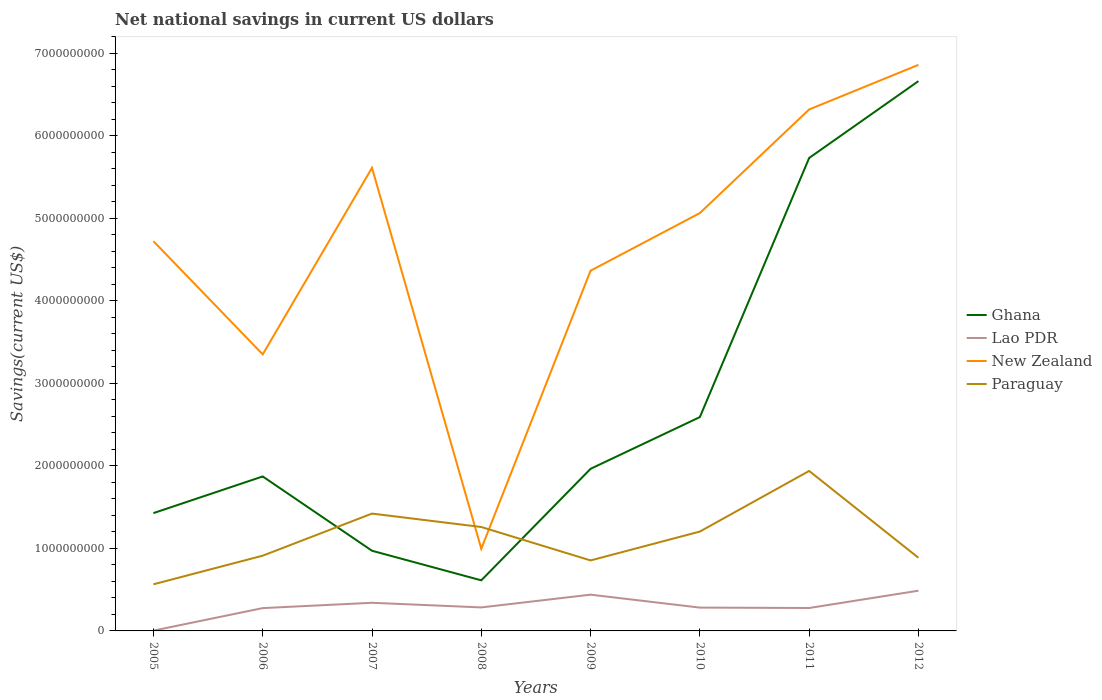How many different coloured lines are there?
Give a very brief answer. 4. Is the number of lines equal to the number of legend labels?
Your answer should be very brief. Yes. Across all years, what is the maximum net national savings in New Zealand?
Keep it short and to the point. 9.96e+08. In which year was the net national savings in New Zealand maximum?
Ensure brevity in your answer.  2008. What is the total net national savings in Lao PDR in the graph?
Ensure brevity in your answer.  -2.10e+08. What is the difference between the highest and the second highest net national savings in New Zealand?
Provide a short and direct response. 5.86e+09. How many lines are there?
Make the answer very short. 4. Are the values on the major ticks of Y-axis written in scientific E-notation?
Make the answer very short. No. Where does the legend appear in the graph?
Offer a very short reply. Center right. How many legend labels are there?
Offer a very short reply. 4. How are the legend labels stacked?
Your response must be concise. Vertical. What is the title of the graph?
Make the answer very short. Net national savings in current US dollars. What is the label or title of the Y-axis?
Provide a succinct answer. Savings(current US$). What is the Savings(current US$) of Ghana in 2005?
Give a very brief answer. 1.43e+09. What is the Savings(current US$) of Lao PDR in 2005?
Offer a very short reply. 3.68e+06. What is the Savings(current US$) in New Zealand in 2005?
Your answer should be compact. 4.72e+09. What is the Savings(current US$) of Paraguay in 2005?
Keep it short and to the point. 5.65e+08. What is the Savings(current US$) in Ghana in 2006?
Your response must be concise. 1.87e+09. What is the Savings(current US$) in Lao PDR in 2006?
Offer a very short reply. 2.77e+08. What is the Savings(current US$) in New Zealand in 2006?
Make the answer very short. 3.35e+09. What is the Savings(current US$) of Paraguay in 2006?
Provide a short and direct response. 9.12e+08. What is the Savings(current US$) of Ghana in 2007?
Your answer should be very brief. 9.72e+08. What is the Savings(current US$) of Lao PDR in 2007?
Your answer should be compact. 3.41e+08. What is the Savings(current US$) in New Zealand in 2007?
Give a very brief answer. 5.61e+09. What is the Savings(current US$) of Paraguay in 2007?
Ensure brevity in your answer.  1.42e+09. What is the Savings(current US$) in Ghana in 2008?
Ensure brevity in your answer.  6.13e+08. What is the Savings(current US$) in Lao PDR in 2008?
Your answer should be very brief. 2.85e+08. What is the Savings(current US$) in New Zealand in 2008?
Offer a very short reply. 9.96e+08. What is the Savings(current US$) in Paraguay in 2008?
Keep it short and to the point. 1.26e+09. What is the Savings(current US$) in Ghana in 2009?
Offer a very short reply. 1.96e+09. What is the Savings(current US$) of Lao PDR in 2009?
Your answer should be very brief. 4.39e+08. What is the Savings(current US$) in New Zealand in 2009?
Keep it short and to the point. 4.37e+09. What is the Savings(current US$) in Paraguay in 2009?
Offer a terse response. 8.54e+08. What is the Savings(current US$) of Ghana in 2010?
Keep it short and to the point. 2.59e+09. What is the Savings(current US$) in Lao PDR in 2010?
Your answer should be very brief. 2.83e+08. What is the Savings(current US$) of New Zealand in 2010?
Provide a succinct answer. 5.06e+09. What is the Savings(current US$) of Paraguay in 2010?
Ensure brevity in your answer.  1.20e+09. What is the Savings(current US$) in Ghana in 2011?
Offer a terse response. 5.73e+09. What is the Savings(current US$) in Lao PDR in 2011?
Your answer should be compact. 2.78e+08. What is the Savings(current US$) of New Zealand in 2011?
Make the answer very short. 6.32e+09. What is the Savings(current US$) in Paraguay in 2011?
Offer a very short reply. 1.94e+09. What is the Savings(current US$) of Ghana in 2012?
Make the answer very short. 6.66e+09. What is the Savings(current US$) in Lao PDR in 2012?
Make the answer very short. 4.88e+08. What is the Savings(current US$) of New Zealand in 2012?
Provide a short and direct response. 6.86e+09. What is the Savings(current US$) of Paraguay in 2012?
Your answer should be compact. 8.86e+08. Across all years, what is the maximum Savings(current US$) of Ghana?
Make the answer very short. 6.66e+09. Across all years, what is the maximum Savings(current US$) in Lao PDR?
Your answer should be very brief. 4.88e+08. Across all years, what is the maximum Savings(current US$) of New Zealand?
Keep it short and to the point. 6.86e+09. Across all years, what is the maximum Savings(current US$) of Paraguay?
Ensure brevity in your answer.  1.94e+09. Across all years, what is the minimum Savings(current US$) of Ghana?
Offer a very short reply. 6.13e+08. Across all years, what is the minimum Savings(current US$) in Lao PDR?
Give a very brief answer. 3.68e+06. Across all years, what is the minimum Savings(current US$) of New Zealand?
Your answer should be very brief. 9.96e+08. Across all years, what is the minimum Savings(current US$) in Paraguay?
Give a very brief answer. 5.65e+08. What is the total Savings(current US$) in Ghana in the graph?
Provide a succinct answer. 2.18e+1. What is the total Savings(current US$) in Lao PDR in the graph?
Offer a terse response. 2.39e+09. What is the total Savings(current US$) in New Zealand in the graph?
Make the answer very short. 3.73e+1. What is the total Savings(current US$) of Paraguay in the graph?
Provide a succinct answer. 9.04e+09. What is the difference between the Savings(current US$) in Ghana in 2005 and that in 2006?
Your answer should be very brief. -4.44e+08. What is the difference between the Savings(current US$) in Lao PDR in 2005 and that in 2006?
Offer a terse response. -2.73e+08. What is the difference between the Savings(current US$) in New Zealand in 2005 and that in 2006?
Provide a short and direct response. 1.37e+09. What is the difference between the Savings(current US$) in Paraguay in 2005 and that in 2006?
Your answer should be compact. -3.47e+08. What is the difference between the Savings(current US$) in Ghana in 2005 and that in 2007?
Offer a very short reply. 4.56e+08. What is the difference between the Savings(current US$) in Lao PDR in 2005 and that in 2007?
Offer a terse response. -3.37e+08. What is the difference between the Savings(current US$) of New Zealand in 2005 and that in 2007?
Offer a terse response. -8.89e+08. What is the difference between the Savings(current US$) in Paraguay in 2005 and that in 2007?
Provide a short and direct response. -8.57e+08. What is the difference between the Savings(current US$) of Ghana in 2005 and that in 2008?
Offer a very short reply. 8.15e+08. What is the difference between the Savings(current US$) of Lao PDR in 2005 and that in 2008?
Give a very brief answer. -2.81e+08. What is the difference between the Savings(current US$) in New Zealand in 2005 and that in 2008?
Offer a very short reply. 3.73e+09. What is the difference between the Savings(current US$) of Paraguay in 2005 and that in 2008?
Ensure brevity in your answer.  -6.94e+08. What is the difference between the Savings(current US$) of Ghana in 2005 and that in 2009?
Your answer should be very brief. -5.37e+08. What is the difference between the Savings(current US$) in Lao PDR in 2005 and that in 2009?
Give a very brief answer. -4.36e+08. What is the difference between the Savings(current US$) of New Zealand in 2005 and that in 2009?
Provide a short and direct response. 3.58e+08. What is the difference between the Savings(current US$) in Paraguay in 2005 and that in 2009?
Provide a short and direct response. -2.89e+08. What is the difference between the Savings(current US$) in Ghana in 2005 and that in 2010?
Provide a short and direct response. -1.16e+09. What is the difference between the Savings(current US$) of Lao PDR in 2005 and that in 2010?
Ensure brevity in your answer.  -2.79e+08. What is the difference between the Savings(current US$) in New Zealand in 2005 and that in 2010?
Offer a very short reply. -3.41e+08. What is the difference between the Savings(current US$) in Paraguay in 2005 and that in 2010?
Provide a succinct answer. -6.39e+08. What is the difference between the Savings(current US$) in Ghana in 2005 and that in 2011?
Make the answer very short. -4.30e+09. What is the difference between the Savings(current US$) in Lao PDR in 2005 and that in 2011?
Offer a terse response. -2.74e+08. What is the difference between the Savings(current US$) of New Zealand in 2005 and that in 2011?
Your response must be concise. -1.60e+09. What is the difference between the Savings(current US$) of Paraguay in 2005 and that in 2011?
Your answer should be compact. -1.37e+09. What is the difference between the Savings(current US$) of Ghana in 2005 and that in 2012?
Provide a short and direct response. -5.24e+09. What is the difference between the Savings(current US$) of Lao PDR in 2005 and that in 2012?
Keep it short and to the point. -4.84e+08. What is the difference between the Savings(current US$) in New Zealand in 2005 and that in 2012?
Your answer should be compact. -2.14e+09. What is the difference between the Savings(current US$) of Paraguay in 2005 and that in 2012?
Provide a short and direct response. -3.21e+08. What is the difference between the Savings(current US$) in Ghana in 2006 and that in 2007?
Offer a terse response. 9.01e+08. What is the difference between the Savings(current US$) of Lao PDR in 2006 and that in 2007?
Ensure brevity in your answer.  -6.46e+07. What is the difference between the Savings(current US$) in New Zealand in 2006 and that in 2007?
Your answer should be very brief. -2.26e+09. What is the difference between the Savings(current US$) in Paraguay in 2006 and that in 2007?
Ensure brevity in your answer.  -5.10e+08. What is the difference between the Savings(current US$) in Ghana in 2006 and that in 2008?
Make the answer very short. 1.26e+09. What is the difference between the Savings(current US$) in Lao PDR in 2006 and that in 2008?
Your answer should be very brief. -8.35e+06. What is the difference between the Savings(current US$) of New Zealand in 2006 and that in 2008?
Offer a terse response. 2.36e+09. What is the difference between the Savings(current US$) in Paraguay in 2006 and that in 2008?
Provide a short and direct response. -3.47e+08. What is the difference between the Savings(current US$) in Ghana in 2006 and that in 2009?
Your answer should be very brief. -9.25e+07. What is the difference between the Savings(current US$) of Lao PDR in 2006 and that in 2009?
Provide a short and direct response. -1.63e+08. What is the difference between the Savings(current US$) in New Zealand in 2006 and that in 2009?
Provide a short and direct response. -1.01e+09. What is the difference between the Savings(current US$) in Paraguay in 2006 and that in 2009?
Ensure brevity in your answer.  5.76e+07. What is the difference between the Savings(current US$) of Ghana in 2006 and that in 2010?
Ensure brevity in your answer.  -7.19e+08. What is the difference between the Savings(current US$) of Lao PDR in 2006 and that in 2010?
Give a very brief answer. -6.13e+06. What is the difference between the Savings(current US$) of New Zealand in 2006 and that in 2010?
Provide a short and direct response. -1.71e+09. What is the difference between the Savings(current US$) in Paraguay in 2006 and that in 2010?
Make the answer very short. -2.92e+08. What is the difference between the Savings(current US$) of Ghana in 2006 and that in 2011?
Offer a terse response. -3.86e+09. What is the difference between the Savings(current US$) of Lao PDR in 2006 and that in 2011?
Give a very brief answer. -1.20e+06. What is the difference between the Savings(current US$) of New Zealand in 2006 and that in 2011?
Your response must be concise. -2.97e+09. What is the difference between the Savings(current US$) in Paraguay in 2006 and that in 2011?
Give a very brief answer. -1.03e+09. What is the difference between the Savings(current US$) of Ghana in 2006 and that in 2012?
Give a very brief answer. -4.79e+09. What is the difference between the Savings(current US$) of Lao PDR in 2006 and that in 2012?
Offer a very short reply. -2.11e+08. What is the difference between the Savings(current US$) of New Zealand in 2006 and that in 2012?
Provide a short and direct response. -3.51e+09. What is the difference between the Savings(current US$) of Paraguay in 2006 and that in 2012?
Provide a succinct answer. 2.55e+07. What is the difference between the Savings(current US$) in Ghana in 2007 and that in 2008?
Provide a succinct answer. 3.59e+08. What is the difference between the Savings(current US$) of Lao PDR in 2007 and that in 2008?
Ensure brevity in your answer.  5.62e+07. What is the difference between the Savings(current US$) of New Zealand in 2007 and that in 2008?
Offer a terse response. 4.62e+09. What is the difference between the Savings(current US$) in Paraguay in 2007 and that in 2008?
Offer a terse response. 1.63e+08. What is the difference between the Savings(current US$) of Ghana in 2007 and that in 2009?
Keep it short and to the point. -9.93e+08. What is the difference between the Savings(current US$) of Lao PDR in 2007 and that in 2009?
Provide a short and direct response. -9.83e+07. What is the difference between the Savings(current US$) of New Zealand in 2007 and that in 2009?
Give a very brief answer. 1.25e+09. What is the difference between the Savings(current US$) of Paraguay in 2007 and that in 2009?
Offer a very short reply. 5.68e+08. What is the difference between the Savings(current US$) in Ghana in 2007 and that in 2010?
Keep it short and to the point. -1.62e+09. What is the difference between the Savings(current US$) in Lao PDR in 2007 and that in 2010?
Your answer should be compact. 5.84e+07. What is the difference between the Savings(current US$) in New Zealand in 2007 and that in 2010?
Give a very brief answer. 5.48e+08. What is the difference between the Savings(current US$) in Paraguay in 2007 and that in 2010?
Provide a short and direct response. 2.18e+08. What is the difference between the Savings(current US$) of Ghana in 2007 and that in 2011?
Give a very brief answer. -4.76e+09. What is the difference between the Savings(current US$) of Lao PDR in 2007 and that in 2011?
Keep it short and to the point. 6.34e+07. What is the difference between the Savings(current US$) in New Zealand in 2007 and that in 2011?
Provide a short and direct response. -7.08e+08. What is the difference between the Savings(current US$) of Paraguay in 2007 and that in 2011?
Offer a very short reply. -5.17e+08. What is the difference between the Savings(current US$) in Ghana in 2007 and that in 2012?
Your answer should be compact. -5.69e+09. What is the difference between the Savings(current US$) of Lao PDR in 2007 and that in 2012?
Your response must be concise. -1.47e+08. What is the difference between the Savings(current US$) of New Zealand in 2007 and that in 2012?
Provide a short and direct response. -1.25e+09. What is the difference between the Savings(current US$) in Paraguay in 2007 and that in 2012?
Give a very brief answer. 5.36e+08. What is the difference between the Savings(current US$) in Ghana in 2008 and that in 2009?
Keep it short and to the point. -1.35e+09. What is the difference between the Savings(current US$) in Lao PDR in 2008 and that in 2009?
Offer a very short reply. -1.55e+08. What is the difference between the Savings(current US$) in New Zealand in 2008 and that in 2009?
Provide a short and direct response. -3.37e+09. What is the difference between the Savings(current US$) in Paraguay in 2008 and that in 2009?
Your answer should be compact. 4.05e+08. What is the difference between the Savings(current US$) in Ghana in 2008 and that in 2010?
Keep it short and to the point. -1.98e+09. What is the difference between the Savings(current US$) in Lao PDR in 2008 and that in 2010?
Offer a terse response. 2.21e+06. What is the difference between the Savings(current US$) in New Zealand in 2008 and that in 2010?
Offer a very short reply. -4.07e+09. What is the difference between the Savings(current US$) of Paraguay in 2008 and that in 2010?
Ensure brevity in your answer.  5.52e+07. What is the difference between the Savings(current US$) of Ghana in 2008 and that in 2011?
Give a very brief answer. -5.12e+09. What is the difference between the Savings(current US$) in Lao PDR in 2008 and that in 2011?
Your answer should be very brief. 7.15e+06. What is the difference between the Savings(current US$) of New Zealand in 2008 and that in 2011?
Your answer should be compact. -5.32e+09. What is the difference between the Savings(current US$) in Paraguay in 2008 and that in 2011?
Keep it short and to the point. -6.79e+08. What is the difference between the Savings(current US$) in Ghana in 2008 and that in 2012?
Offer a terse response. -6.05e+09. What is the difference between the Savings(current US$) of Lao PDR in 2008 and that in 2012?
Keep it short and to the point. -2.03e+08. What is the difference between the Savings(current US$) in New Zealand in 2008 and that in 2012?
Ensure brevity in your answer.  -5.86e+09. What is the difference between the Savings(current US$) of Paraguay in 2008 and that in 2012?
Give a very brief answer. 3.73e+08. What is the difference between the Savings(current US$) in Ghana in 2009 and that in 2010?
Offer a terse response. -6.27e+08. What is the difference between the Savings(current US$) in Lao PDR in 2009 and that in 2010?
Ensure brevity in your answer.  1.57e+08. What is the difference between the Savings(current US$) in New Zealand in 2009 and that in 2010?
Make the answer very short. -6.98e+08. What is the difference between the Savings(current US$) in Paraguay in 2009 and that in 2010?
Keep it short and to the point. -3.50e+08. What is the difference between the Savings(current US$) in Ghana in 2009 and that in 2011?
Offer a very short reply. -3.77e+09. What is the difference between the Savings(current US$) of Lao PDR in 2009 and that in 2011?
Offer a terse response. 1.62e+08. What is the difference between the Savings(current US$) of New Zealand in 2009 and that in 2011?
Your response must be concise. -1.95e+09. What is the difference between the Savings(current US$) of Paraguay in 2009 and that in 2011?
Offer a terse response. -1.08e+09. What is the difference between the Savings(current US$) in Ghana in 2009 and that in 2012?
Provide a short and direct response. -4.70e+09. What is the difference between the Savings(current US$) in Lao PDR in 2009 and that in 2012?
Make the answer very short. -4.82e+07. What is the difference between the Savings(current US$) in New Zealand in 2009 and that in 2012?
Provide a succinct answer. -2.49e+09. What is the difference between the Savings(current US$) in Paraguay in 2009 and that in 2012?
Ensure brevity in your answer.  -3.21e+07. What is the difference between the Savings(current US$) in Ghana in 2010 and that in 2011?
Give a very brief answer. -3.14e+09. What is the difference between the Savings(current US$) in Lao PDR in 2010 and that in 2011?
Keep it short and to the point. 4.94e+06. What is the difference between the Savings(current US$) in New Zealand in 2010 and that in 2011?
Your answer should be compact. -1.26e+09. What is the difference between the Savings(current US$) in Paraguay in 2010 and that in 2011?
Give a very brief answer. -7.35e+08. What is the difference between the Savings(current US$) in Ghana in 2010 and that in 2012?
Give a very brief answer. -4.07e+09. What is the difference between the Savings(current US$) of Lao PDR in 2010 and that in 2012?
Provide a succinct answer. -2.05e+08. What is the difference between the Savings(current US$) in New Zealand in 2010 and that in 2012?
Make the answer very short. -1.80e+09. What is the difference between the Savings(current US$) in Paraguay in 2010 and that in 2012?
Make the answer very short. 3.18e+08. What is the difference between the Savings(current US$) in Ghana in 2011 and that in 2012?
Keep it short and to the point. -9.31e+08. What is the difference between the Savings(current US$) of Lao PDR in 2011 and that in 2012?
Your response must be concise. -2.10e+08. What is the difference between the Savings(current US$) in New Zealand in 2011 and that in 2012?
Offer a terse response. -5.40e+08. What is the difference between the Savings(current US$) in Paraguay in 2011 and that in 2012?
Provide a short and direct response. 1.05e+09. What is the difference between the Savings(current US$) in Ghana in 2005 and the Savings(current US$) in Lao PDR in 2006?
Ensure brevity in your answer.  1.15e+09. What is the difference between the Savings(current US$) in Ghana in 2005 and the Savings(current US$) in New Zealand in 2006?
Provide a short and direct response. -1.92e+09. What is the difference between the Savings(current US$) of Ghana in 2005 and the Savings(current US$) of Paraguay in 2006?
Offer a very short reply. 5.16e+08. What is the difference between the Savings(current US$) of Lao PDR in 2005 and the Savings(current US$) of New Zealand in 2006?
Give a very brief answer. -3.35e+09. What is the difference between the Savings(current US$) in Lao PDR in 2005 and the Savings(current US$) in Paraguay in 2006?
Offer a very short reply. -9.08e+08. What is the difference between the Savings(current US$) of New Zealand in 2005 and the Savings(current US$) of Paraguay in 2006?
Ensure brevity in your answer.  3.81e+09. What is the difference between the Savings(current US$) of Ghana in 2005 and the Savings(current US$) of Lao PDR in 2007?
Give a very brief answer. 1.09e+09. What is the difference between the Savings(current US$) in Ghana in 2005 and the Savings(current US$) in New Zealand in 2007?
Your answer should be compact. -4.18e+09. What is the difference between the Savings(current US$) in Ghana in 2005 and the Savings(current US$) in Paraguay in 2007?
Keep it short and to the point. 5.76e+06. What is the difference between the Savings(current US$) in Lao PDR in 2005 and the Savings(current US$) in New Zealand in 2007?
Provide a short and direct response. -5.61e+09. What is the difference between the Savings(current US$) of Lao PDR in 2005 and the Savings(current US$) of Paraguay in 2007?
Provide a succinct answer. -1.42e+09. What is the difference between the Savings(current US$) in New Zealand in 2005 and the Savings(current US$) in Paraguay in 2007?
Give a very brief answer. 3.30e+09. What is the difference between the Savings(current US$) of Ghana in 2005 and the Savings(current US$) of Lao PDR in 2008?
Your answer should be very brief. 1.14e+09. What is the difference between the Savings(current US$) of Ghana in 2005 and the Savings(current US$) of New Zealand in 2008?
Make the answer very short. 4.32e+08. What is the difference between the Savings(current US$) in Ghana in 2005 and the Savings(current US$) in Paraguay in 2008?
Your answer should be very brief. 1.68e+08. What is the difference between the Savings(current US$) in Lao PDR in 2005 and the Savings(current US$) in New Zealand in 2008?
Provide a short and direct response. -9.92e+08. What is the difference between the Savings(current US$) in Lao PDR in 2005 and the Savings(current US$) in Paraguay in 2008?
Offer a terse response. -1.26e+09. What is the difference between the Savings(current US$) of New Zealand in 2005 and the Savings(current US$) of Paraguay in 2008?
Keep it short and to the point. 3.46e+09. What is the difference between the Savings(current US$) in Ghana in 2005 and the Savings(current US$) in Lao PDR in 2009?
Provide a short and direct response. 9.88e+08. What is the difference between the Savings(current US$) in Ghana in 2005 and the Savings(current US$) in New Zealand in 2009?
Make the answer very short. -2.94e+09. What is the difference between the Savings(current US$) in Ghana in 2005 and the Savings(current US$) in Paraguay in 2009?
Provide a succinct answer. 5.73e+08. What is the difference between the Savings(current US$) of Lao PDR in 2005 and the Savings(current US$) of New Zealand in 2009?
Offer a very short reply. -4.36e+09. What is the difference between the Savings(current US$) of Lao PDR in 2005 and the Savings(current US$) of Paraguay in 2009?
Your answer should be compact. -8.51e+08. What is the difference between the Savings(current US$) in New Zealand in 2005 and the Savings(current US$) in Paraguay in 2009?
Your answer should be compact. 3.87e+09. What is the difference between the Savings(current US$) in Ghana in 2005 and the Savings(current US$) in Lao PDR in 2010?
Offer a terse response. 1.15e+09. What is the difference between the Savings(current US$) in Ghana in 2005 and the Savings(current US$) in New Zealand in 2010?
Your answer should be compact. -3.64e+09. What is the difference between the Savings(current US$) of Ghana in 2005 and the Savings(current US$) of Paraguay in 2010?
Provide a short and direct response. 2.24e+08. What is the difference between the Savings(current US$) of Lao PDR in 2005 and the Savings(current US$) of New Zealand in 2010?
Ensure brevity in your answer.  -5.06e+09. What is the difference between the Savings(current US$) of Lao PDR in 2005 and the Savings(current US$) of Paraguay in 2010?
Keep it short and to the point. -1.20e+09. What is the difference between the Savings(current US$) of New Zealand in 2005 and the Savings(current US$) of Paraguay in 2010?
Provide a short and direct response. 3.52e+09. What is the difference between the Savings(current US$) of Ghana in 2005 and the Savings(current US$) of Lao PDR in 2011?
Offer a very short reply. 1.15e+09. What is the difference between the Savings(current US$) in Ghana in 2005 and the Savings(current US$) in New Zealand in 2011?
Make the answer very short. -4.89e+09. What is the difference between the Savings(current US$) in Ghana in 2005 and the Savings(current US$) in Paraguay in 2011?
Offer a very short reply. -5.11e+08. What is the difference between the Savings(current US$) of Lao PDR in 2005 and the Savings(current US$) of New Zealand in 2011?
Provide a succinct answer. -6.32e+09. What is the difference between the Savings(current US$) of Lao PDR in 2005 and the Savings(current US$) of Paraguay in 2011?
Give a very brief answer. -1.94e+09. What is the difference between the Savings(current US$) in New Zealand in 2005 and the Savings(current US$) in Paraguay in 2011?
Your response must be concise. 2.78e+09. What is the difference between the Savings(current US$) of Ghana in 2005 and the Savings(current US$) of Lao PDR in 2012?
Offer a terse response. 9.40e+08. What is the difference between the Savings(current US$) of Ghana in 2005 and the Savings(current US$) of New Zealand in 2012?
Ensure brevity in your answer.  -5.43e+09. What is the difference between the Savings(current US$) of Ghana in 2005 and the Savings(current US$) of Paraguay in 2012?
Provide a short and direct response. 5.41e+08. What is the difference between the Savings(current US$) of Lao PDR in 2005 and the Savings(current US$) of New Zealand in 2012?
Ensure brevity in your answer.  -6.86e+09. What is the difference between the Savings(current US$) in Lao PDR in 2005 and the Savings(current US$) in Paraguay in 2012?
Make the answer very short. -8.83e+08. What is the difference between the Savings(current US$) of New Zealand in 2005 and the Savings(current US$) of Paraguay in 2012?
Offer a very short reply. 3.84e+09. What is the difference between the Savings(current US$) in Ghana in 2006 and the Savings(current US$) in Lao PDR in 2007?
Provide a short and direct response. 1.53e+09. What is the difference between the Savings(current US$) in Ghana in 2006 and the Savings(current US$) in New Zealand in 2007?
Offer a terse response. -3.74e+09. What is the difference between the Savings(current US$) of Ghana in 2006 and the Savings(current US$) of Paraguay in 2007?
Your answer should be very brief. 4.50e+08. What is the difference between the Savings(current US$) in Lao PDR in 2006 and the Savings(current US$) in New Zealand in 2007?
Provide a succinct answer. -5.34e+09. What is the difference between the Savings(current US$) in Lao PDR in 2006 and the Savings(current US$) in Paraguay in 2007?
Make the answer very short. -1.15e+09. What is the difference between the Savings(current US$) of New Zealand in 2006 and the Savings(current US$) of Paraguay in 2007?
Your answer should be compact. 1.93e+09. What is the difference between the Savings(current US$) of Ghana in 2006 and the Savings(current US$) of Lao PDR in 2008?
Your answer should be very brief. 1.59e+09. What is the difference between the Savings(current US$) in Ghana in 2006 and the Savings(current US$) in New Zealand in 2008?
Keep it short and to the point. 8.76e+08. What is the difference between the Savings(current US$) in Ghana in 2006 and the Savings(current US$) in Paraguay in 2008?
Give a very brief answer. 6.13e+08. What is the difference between the Savings(current US$) in Lao PDR in 2006 and the Savings(current US$) in New Zealand in 2008?
Your answer should be very brief. -7.19e+08. What is the difference between the Savings(current US$) of Lao PDR in 2006 and the Savings(current US$) of Paraguay in 2008?
Offer a very short reply. -9.83e+08. What is the difference between the Savings(current US$) of New Zealand in 2006 and the Savings(current US$) of Paraguay in 2008?
Make the answer very short. 2.09e+09. What is the difference between the Savings(current US$) of Ghana in 2006 and the Savings(current US$) of Lao PDR in 2009?
Keep it short and to the point. 1.43e+09. What is the difference between the Savings(current US$) of Ghana in 2006 and the Savings(current US$) of New Zealand in 2009?
Your answer should be very brief. -2.49e+09. What is the difference between the Savings(current US$) of Ghana in 2006 and the Savings(current US$) of Paraguay in 2009?
Offer a terse response. 1.02e+09. What is the difference between the Savings(current US$) in Lao PDR in 2006 and the Savings(current US$) in New Zealand in 2009?
Keep it short and to the point. -4.09e+09. What is the difference between the Savings(current US$) of Lao PDR in 2006 and the Savings(current US$) of Paraguay in 2009?
Make the answer very short. -5.78e+08. What is the difference between the Savings(current US$) in New Zealand in 2006 and the Savings(current US$) in Paraguay in 2009?
Your response must be concise. 2.50e+09. What is the difference between the Savings(current US$) in Ghana in 2006 and the Savings(current US$) in Lao PDR in 2010?
Your answer should be compact. 1.59e+09. What is the difference between the Savings(current US$) in Ghana in 2006 and the Savings(current US$) in New Zealand in 2010?
Offer a very short reply. -3.19e+09. What is the difference between the Savings(current US$) in Ghana in 2006 and the Savings(current US$) in Paraguay in 2010?
Offer a very short reply. 6.68e+08. What is the difference between the Savings(current US$) in Lao PDR in 2006 and the Savings(current US$) in New Zealand in 2010?
Offer a terse response. -4.79e+09. What is the difference between the Savings(current US$) of Lao PDR in 2006 and the Savings(current US$) of Paraguay in 2010?
Give a very brief answer. -9.28e+08. What is the difference between the Savings(current US$) in New Zealand in 2006 and the Savings(current US$) in Paraguay in 2010?
Your answer should be compact. 2.15e+09. What is the difference between the Savings(current US$) in Ghana in 2006 and the Savings(current US$) in Lao PDR in 2011?
Offer a terse response. 1.59e+09. What is the difference between the Savings(current US$) in Ghana in 2006 and the Savings(current US$) in New Zealand in 2011?
Ensure brevity in your answer.  -4.45e+09. What is the difference between the Savings(current US$) of Ghana in 2006 and the Savings(current US$) of Paraguay in 2011?
Your answer should be compact. -6.66e+07. What is the difference between the Savings(current US$) in Lao PDR in 2006 and the Savings(current US$) in New Zealand in 2011?
Provide a short and direct response. -6.04e+09. What is the difference between the Savings(current US$) in Lao PDR in 2006 and the Savings(current US$) in Paraguay in 2011?
Your answer should be very brief. -1.66e+09. What is the difference between the Savings(current US$) in New Zealand in 2006 and the Savings(current US$) in Paraguay in 2011?
Your answer should be very brief. 1.41e+09. What is the difference between the Savings(current US$) of Ghana in 2006 and the Savings(current US$) of Lao PDR in 2012?
Keep it short and to the point. 1.38e+09. What is the difference between the Savings(current US$) in Ghana in 2006 and the Savings(current US$) in New Zealand in 2012?
Your response must be concise. -4.99e+09. What is the difference between the Savings(current US$) in Ghana in 2006 and the Savings(current US$) in Paraguay in 2012?
Provide a succinct answer. 9.86e+08. What is the difference between the Savings(current US$) of Lao PDR in 2006 and the Savings(current US$) of New Zealand in 2012?
Make the answer very short. -6.58e+09. What is the difference between the Savings(current US$) of Lao PDR in 2006 and the Savings(current US$) of Paraguay in 2012?
Your answer should be compact. -6.10e+08. What is the difference between the Savings(current US$) of New Zealand in 2006 and the Savings(current US$) of Paraguay in 2012?
Provide a short and direct response. 2.46e+09. What is the difference between the Savings(current US$) in Ghana in 2007 and the Savings(current US$) in Lao PDR in 2008?
Your response must be concise. 6.87e+08. What is the difference between the Savings(current US$) of Ghana in 2007 and the Savings(current US$) of New Zealand in 2008?
Give a very brief answer. -2.44e+07. What is the difference between the Savings(current US$) of Ghana in 2007 and the Savings(current US$) of Paraguay in 2008?
Ensure brevity in your answer.  -2.88e+08. What is the difference between the Savings(current US$) of Lao PDR in 2007 and the Savings(current US$) of New Zealand in 2008?
Your answer should be compact. -6.55e+08. What is the difference between the Savings(current US$) of Lao PDR in 2007 and the Savings(current US$) of Paraguay in 2008?
Ensure brevity in your answer.  -9.18e+08. What is the difference between the Savings(current US$) of New Zealand in 2007 and the Savings(current US$) of Paraguay in 2008?
Offer a very short reply. 4.35e+09. What is the difference between the Savings(current US$) in Ghana in 2007 and the Savings(current US$) in Lao PDR in 2009?
Your answer should be compact. 5.32e+08. What is the difference between the Savings(current US$) of Ghana in 2007 and the Savings(current US$) of New Zealand in 2009?
Ensure brevity in your answer.  -3.39e+09. What is the difference between the Savings(current US$) in Ghana in 2007 and the Savings(current US$) in Paraguay in 2009?
Make the answer very short. 1.17e+08. What is the difference between the Savings(current US$) in Lao PDR in 2007 and the Savings(current US$) in New Zealand in 2009?
Your answer should be very brief. -4.02e+09. What is the difference between the Savings(current US$) in Lao PDR in 2007 and the Savings(current US$) in Paraguay in 2009?
Your answer should be very brief. -5.13e+08. What is the difference between the Savings(current US$) in New Zealand in 2007 and the Savings(current US$) in Paraguay in 2009?
Offer a terse response. 4.76e+09. What is the difference between the Savings(current US$) in Ghana in 2007 and the Savings(current US$) in Lao PDR in 2010?
Your answer should be compact. 6.89e+08. What is the difference between the Savings(current US$) of Ghana in 2007 and the Savings(current US$) of New Zealand in 2010?
Your answer should be compact. -4.09e+09. What is the difference between the Savings(current US$) in Ghana in 2007 and the Savings(current US$) in Paraguay in 2010?
Provide a succinct answer. -2.33e+08. What is the difference between the Savings(current US$) in Lao PDR in 2007 and the Savings(current US$) in New Zealand in 2010?
Provide a short and direct response. -4.72e+09. What is the difference between the Savings(current US$) in Lao PDR in 2007 and the Savings(current US$) in Paraguay in 2010?
Offer a terse response. -8.63e+08. What is the difference between the Savings(current US$) of New Zealand in 2007 and the Savings(current US$) of Paraguay in 2010?
Offer a terse response. 4.41e+09. What is the difference between the Savings(current US$) of Ghana in 2007 and the Savings(current US$) of Lao PDR in 2011?
Keep it short and to the point. 6.94e+08. What is the difference between the Savings(current US$) of Ghana in 2007 and the Savings(current US$) of New Zealand in 2011?
Your answer should be compact. -5.35e+09. What is the difference between the Savings(current US$) of Ghana in 2007 and the Savings(current US$) of Paraguay in 2011?
Your answer should be compact. -9.67e+08. What is the difference between the Savings(current US$) of Lao PDR in 2007 and the Savings(current US$) of New Zealand in 2011?
Make the answer very short. -5.98e+09. What is the difference between the Savings(current US$) in Lao PDR in 2007 and the Savings(current US$) in Paraguay in 2011?
Give a very brief answer. -1.60e+09. What is the difference between the Savings(current US$) in New Zealand in 2007 and the Savings(current US$) in Paraguay in 2011?
Offer a terse response. 3.67e+09. What is the difference between the Savings(current US$) in Ghana in 2007 and the Savings(current US$) in Lao PDR in 2012?
Ensure brevity in your answer.  4.84e+08. What is the difference between the Savings(current US$) in Ghana in 2007 and the Savings(current US$) in New Zealand in 2012?
Provide a short and direct response. -5.89e+09. What is the difference between the Savings(current US$) of Ghana in 2007 and the Savings(current US$) of Paraguay in 2012?
Make the answer very short. 8.51e+07. What is the difference between the Savings(current US$) of Lao PDR in 2007 and the Savings(current US$) of New Zealand in 2012?
Offer a terse response. -6.52e+09. What is the difference between the Savings(current US$) of Lao PDR in 2007 and the Savings(current US$) of Paraguay in 2012?
Give a very brief answer. -5.45e+08. What is the difference between the Savings(current US$) of New Zealand in 2007 and the Savings(current US$) of Paraguay in 2012?
Your response must be concise. 4.73e+09. What is the difference between the Savings(current US$) in Ghana in 2008 and the Savings(current US$) in Lao PDR in 2009?
Provide a short and direct response. 1.74e+08. What is the difference between the Savings(current US$) in Ghana in 2008 and the Savings(current US$) in New Zealand in 2009?
Offer a very short reply. -3.75e+09. What is the difference between the Savings(current US$) of Ghana in 2008 and the Savings(current US$) of Paraguay in 2009?
Keep it short and to the point. -2.41e+08. What is the difference between the Savings(current US$) in Lao PDR in 2008 and the Savings(current US$) in New Zealand in 2009?
Offer a very short reply. -4.08e+09. What is the difference between the Savings(current US$) of Lao PDR in 2008 and the Savings(current US$) of Paraguay in 2009?
Keep it short and to the point. -5.69e+08. What is the difference between the Savings(current US$) in New Zealand in 2008 and the Savings(current US$) in Paraguay in 2009?
Provide a short and direct response. 1.42e+08. What is the difference between the Savings(current US$) in Ghana in 2008 and the Savings(current US$) in Lao PDR in 2010?
Make the answer very short. 3.30e+08. What is the difference between the Savings(current US$) of Ghana in 2008 and the Savings(current US$) of New Zealand in 2010?
Provide a short and direct response. -4.45e+09. What is the difference between the Savings(current US$) of Ghana in 2008 and the Savings(current US$) of Paraguay in 2010?
Provide a short and direct response. -5.91e+08. What is the difference between the Savings(current US$) in Lao PDR in 2008 and the Savings(current US$) in New Zealand in 2010?
Keep it short and to the point. -4.78e+09. What is the difference between the Savings(current US$) in Lao PDR in 2008 and the Savings(current US$) in Paraguay in 2010?
Make the answer very short. -9.19e+08. What is the difference between the Savings(current US$) of New Zealand in 2008 and the Savings(current US$) of Paraguay in 2010?
Your answer should be very brief. -2.08e+08. What is the difference between the Savings(current US$) in Ghana in 2008 and the Savings(current US$) in Lao PDR in 2011?
Your answer should be compact. 3.35e+08. What is the difference between the Savings(current US$) in Ghana in 2008 and the Savings(current US$) in New Zealand in 2011?
Keep it short and to the point. -5.71e+09. What is the difference between the Savings(current US$) in Ghana in 2008 and the Savings(current US$) in Paraguay in 2011?
Ensure brevity in your answer.  -1.33e+09. What is the difference between the Savings(current US$) in Lao PDR in 2008 and the Savings(current US$) in New Zealand in 2011?
Give a very brief answer. -6.03e+09. What is the difference between the Savings(current US$) of Lao PDR in 2008 and the Savings(current US$) of Paraguay in 2011?
Keep it short and to the point. -1.65e+09. What is the difference between the Savings(current US$) of New Zealand in 2008 and the Savings(current US$) of Paraguay in 2011?
Offer a very short reply. -9.43e+08. What is the difference between the Savings(current US$) in Ghana in 2008 and the Savings(current US$) in Lao PDR in 2012?
Provide a succinct answer. 1.25e+08. What is the difference between the Savings(current US$) in Ghana in 2008 and the Savings(current US$) in New Zealand in 2012?
Your response must be concise. -6.25e+09. What is the difference between the Savings(current US$) of Ghana in 2008 and the Savings(current US$) of Paraguay in 2012?
Make the answer very short. -2.73e+08. What is the difference between the Savings(current US$) in Lao PDR in 2008 and the Savings(current US$) in New Zealand in 2012?
Make the answer very short. -6.58e+09. What is the difference between the Savings(current US$) in Lao PDR in 2008 and the Savings(current US$) in Paraguay in 2012?
Your answer should be very brief. -6.02e+08. What is the difference between the Savings(current US$) in New Zealand in 2008 and the Savings(current US$) in Paraguay in 2012?
Give a very brief answer. 1.09e+08. What is the difference between the Savings(current US$) of Ghana in 2009 and the Savings(current US$) of Lao PDR in 2010?
Offer a terse response. 1.68e+09. What is the difference between the Savings(current US$) in Ghana in 2009 and the Savings(current US$) in New Zealand in 2010?
Make the answer very short. -3.10e+09. What is the difference between the Savings(current US$) of Ghana in 2009 and the Savings(current US$) of Paraguay in 2010?
Give a very brief answer. 7.60e+08. What is the difference between the Savings(current US$) of Lao PDR in 2009 and the Savings(current US$) of New Zealand in 2010?
Provide a succinct answer. -4.62e+09. What is the difference between the Savings(current US$) of Lao PDR in 2009 and the Savings(current US$) of Paraguay in 2010?
Offer a very short reply. -7.65e+08. What is the difference between the Savings(current US$) of New Zealand in 2009 and the Savings(current US$) of Paraguay in 2010?
Ensure brevity in your answer.  3.16e+09. What is the difference between the Savings(current US$) in Ghana in 2009 and the Savings(current US$) in Lao PDR in 2011?
Give a very brief answer. 1.69e+09. What is the difference between the Savings(current US$) in Ghana in 2009 and the Savings(current US$) in New Zealand in 2011?
Keep it short and to the point. -4.36e+09. What is the difference between the Savings(current US$) of Ghana in 2009 and the Savings(current US$) of Paraguay in 2011?
Give a very brief answer. 2.58e+07. What is the difference between the Savings(current US$) in Lao PDR in 2009 and the Savings(current US$) in New Zealand in 2011?
Offer a terse response. -5.88e+09. What is the difference between the Savings(current US$) in Lao PDR in 2009 and the Savings(current US$) in Paraguay in 2011?
Make the answer very short. -1.50e+09. What is the difference between the Savings(current US$) of New Zealand in 2009 and the Savings(current US$) of Paraguay in 2011?
Ensure brevity in your answer.  2.43e+09. What is the difference between the Savings(current US$) in Ghana in 2009 and the Savings(current US$) in Lao PDR in 2012?
Your answer should be very brief. 1.48e+09. What is the difference between the Savings(current US$) in Ghana in 2009 and the Savings(current US$) in New Zealand in 2012?
Provide a short and direct response. -4.90e+09. What is the difference between the Savings(current US$) of Ghana in 2009 and the Savings(current US$) of Paraguay in 2012?
Your answer should be very brief. 1.08e+09. What is the difference between the Savings(current US$) of Lao PDR in 2009 and the Savings(current US$) of New Zealand in 2012?
Your answer should be very brief. -6.42e+09. What is the difference between the Savings(current US$) of Lao PDR in 2009 and the Savings(current US$) of Paraguay in 2012?
Give a very brief answer. -4.47e+08. What is the difference between the Savings(current US$) in New Zealand in 2009 and the Savings(current US$) in Paraguay in 2012?
Give a very brief answer. 3.48e+09. What is the difference between the Savings(current US$) of Ghana in 2010 and the Savings(current US$) of Lao PDR in 2011?
Give a very brief answer. 2.31e+09. What is the difference between the Savings(current US$) in Ghana in 2010 and the Savings(current US$) in New Zealand in 2011?
Your answer should be very brief. -3.73e+09. What is the difference between the Savings(current US$) of Ghana in 2010 and the Savings(current US$) of Paraguay in 2011?
Keep it short and to the point. 6.53e+08. What is the difference between the Savings(current US$) of Lao PDR in 2010 and the Savings(current US$) of New Zealand in 2011?
Offer a very short reply. -6.04e+09. What is the difference between the Savings(current US$) in Lao PDR in 2010 and the Savings(current US$) in Paraguay in 2011?
Provide a succinct answer. -1.66e+09. What is the difference between the Savings(current US$) in New Zealand in 2010 and the Savings(current US$) in Paraguay in 2011?
Keep it short and to the point. 3.13e+09. What is the difference between the Savings(current US$) of Ghana in 2010 and the Savings(current US$) of Lao PDR in 2012?
Offer a terse response. 2.10e+09. What is the difference between the Savings(current US$) in Ghana in 2010 and the Savings(current US$) in New Zealand in 2012?
Offer a very short reply. -4.27e+09. What is the difference between the Savings(current US$) of Ghana in 2010 and the Savings(current US$) of Paraguay in 2012?
Ensure brevity in your answer.  1.70e+09. What is the difference between the Savings(current US$) in Lao PDR in 2010 and the Savings(current US$) in New Zealand in 2012?
Make the answer very short. -6.58e+09. What is the difference between the Savings(current US$) in Lao PDR in 2010 and the Savings(current US$) in Paraguay in 2012?
Make the answer very short. -6.04e+08. What is the difference between the Savings(current US$) in New Zealand in 2010 and the Savings(current US$) in Paraguay in 2012?
Your response must be concise. 4.18e+09. What is the difference between the Savings(current US$) of Ghana in 2011 and the Savings(current US$) of Lao PDR in 2012?
Provide a short and direct response. 5.24e+09. What is the difference between the Savings(current US$) of Ghana in 2011 and the Savings(current US$) of New Zealand in 2012?
Give a very brief answer. -1.13e+09. What is the difference between the Savings(current US$) in Ghana in 2011 and the Savings(current US$) in Paraguay in 2012?
Provide a short and direct response. 4.85e+09. What is the difference between the Savings(current US$) in Lao PDR in 2011 and the Savings(current US$) in New Zealand in 2012?
Provide a short and direct response. -6.58e+09. What is the difference between the Savings(current US$) of Lao PDR in 2011 and the Savings(current US$) of Paraguay in 2012?
Your response must be concise. -6.09e+08. What is the difference between the Savings(current US$) of New Zealand in 2011 and the Savings(current US$) of Paraguay in 2012?
Your answer should be very brief. 5.43e+09. What is the average Savings(current US$) of Ghana per year?
Your response must be concise. 2.73e+09. What is the average Savings(current US$) of Lao PDR per year?
Provide a succinct answer. 2.99e+08. What is the average Savings(current US$) of New Zealand per year?
Your response must be concise. 4.66e+09. What is the average Savings(current US$) of Paraguay per year?
Make the answer very short. 1.13e+09. In the year 2005, what is the difference between the Savings(current US$) in Ghana and Savings(current US$) in Lao PDR?
Offer a terse response. 1.42e+09. In the year 2005, what is the difference between the Savings(current US$) of Ghana and Savings(current US$) of New Zealand?
Provide a short and direct response. -3.30e+09. In the year 2005, what is the difference between the Savings(current US$) in Ghana and Savings(current US$) in Paraguay?
Keep it short and to the point. 8.63e+08. In the year 2005, what is the difference between the Savings(current US$) of Lao PDR and Savings(current US$) of New Zealand?
Keep it short and to the point. -4.72e+09. In the year 2005, what is the difference between the Savings(current US$) in Lao PDR and Savings(current US$) in Paraguay?
Offer a terse response. -5.61e+08. In the year 2005, what is the difference between the Savings(current US$) in New Zealand and Savings(current US$) in Paraguay?
Ensure brevity in your answer.  4.16e+09. In the year 2006, what is the difference between the Savings(current US$) in Ghana and Savings(current US$) in Lao PDR?
Provide a succinct answer. 1.60e+09. In the year 2006, what is the difference between the Savings(current US$) in Ghana and Savings(current US$) in New Zealand?
Offer a very short reply. -1.48e+09. In the year 2006, what is the difference between the Savings(current US$) of Ghana and Savings(current US$) of Paraguay?
Provide a short and direct response. 9.60e+08. In the year 2006, what is the difference between the Savings(current US$) in Lao PDR and Savings(current US$) in New Zealand?
Ensure brevity in your answer.  -3.07e+09. In the year 2006, what is the difference between the Savings(current US$) in Lao PDR and Savings(current US$) in Paraguay?
Offer a very short reply. -6.35e+08. In the year 2006, what is the difference between the Savings(current US$) of New Zealand and Savings(current US$) of Paraguay?
Give a very brief answer. 2.44e+09. In the year 2007, what is the difference between the Savings(current US$) in Ghana and Savings(current US$) in Lao PDR?
Offer a very short reply. 6.30e+08. In the year 2007, what is the difference between the Savings(current US$) of Ghana and Savings(current US$) of New Zealand?
Offer a very short reply. -4.64e+09. In the year 2007, what is the difference between the Savings(current US$) in Ghana and Savings(current US$) in Paraguay?
Offer a very short reply. -4.50e+08. In the year 2007, what is the difference between the Savings(current US$) of Lao PDR and Savings(current US$) of New Zealand?
Make the answer very short. -5.27e+09. In the year 2007, what is the difference between the Savings(current US$) in Lao PDR and Savings(current US$) in Paraguay?
Offer a terse response. -1.08e+09. In the year 2007, what is the difference between the Savings(current US$) of New Zealand and Savings(current US$) of Paraguay?
Provide a short and direct response. 4.19e+09. In the year 2008, what is the difference between the Savings(current US$) in Ghana and Savings(current US$) in Lao PDR?
Your answer should be very brief. 3.28e+08. In the year 2008, what is the difference between the Savings(current US$) in Ghana and Savings(current US$) in New Zealand?
Ensure brevity in your answer.  -3.83e+08. In the year 2008, what is the difference between the Savings(current US$) in Ghana and Savings(current US$) in Paraguay?
Offer a very short reply. -6.46e+08. In the year 2008, what is the difference between the Savings(current US$) in Lao PDR and Savings(current US$) in New Zealand?
Make the answer very short. -7.11e+08. In the year 2008, what is the difference between the Savings(current US$) in Lao PDR and Savings(current US$) in Paraguay?
Ensure brevity in your answer.  -9.74e+08. In the year 2008, what is the difference between the Savings(current US$) of New Zealand and Savings(current US$) of Paraguay?
Your response must be concise. -2.63e+08. In the year 2009, what is the difference between the Savings(current US$) in Ghana and Savings(current US$) in Lao PDR?
Ensure brevity in your answer.  1.53e+09. In the year 2009, what is the difference between the Savings(current US$) in Ghana and Savings(current US$) in New Zealand?
Provide a short and direct response. -2.40e+09. In the year 2009, what is the difference between the Savings(current US$) of Ghana and Savings(current US$) of Paraguay?
Offer a terse response. 1.11e+09. In the year 2009, what is the difference between the Savings(current US$) of Lao PDR and Savings(current US$) of New Zealand?
Make the answer very short. -3.93e+09. In the year 2009, what is the difference between the Savings(current US$) of Lao PDR and Savings(current US$) of Paraguay?
Ensure brevity in your answer.  -4.15e+08. In the year 2009, what is the difference between the Savings(current US$) in New Zealand and Savings(current US$) in Paraguay?
Make the answer very short. 3.51e+09. In the year 2010, what is the difference between the Savings(current US$) in Ghana and Savings(current US$) in Lao PDR?
Offer a terse response. 2.31e+09. In the year 2010, what is the difference between the Savings(current US$) of Ghana and Savings(current US$) of New Zealand?
Your response must be concise. -2.47e+09. In the year 2010, what is the difference between the Savings(current US$) in Ghana and Savings(current US$) in Paraguay?
Keep it short and to the point. 1.39e+09. In the year 2010, what is the difference between the Savings(current US$) in Lao PDR and Savings(current US$) in New Zealand?
Offer a terse response. -4.78e+09. In the year 2010, what is the difference between the Savings(current US$) in Lao PDR and Savings(current US$) in Paraguay?
Your response must be concise. -9.21e+08. In the year 2010, what is the difference between the Savings(current US$) in New Zealand and Savings(current US$) in Paraguay?
Provide a short and direct response. 3.86e+09. In the year 2011, what is the difference between the Savings(current US$) of Ghana and Savings(current US$) of Lao PDR?
Give a very brief answer. 5.45e+09. In the year 2011, what is the difference between the Savings(current US$) in Ghana and Savings(current US$) in New Zealand?
Offer a very short reply. -5.88e+08. In the year 2011, what is the difference between the Savings(current US$) of Ghana and Savings(current US$) of Paraguay?
Offer a very short reply. 3.79e+09. In the year 2011, what is the difference between the Savings(current US$) in Lao PDR and Savings(current US$) in New Zealand?
Provide a succinct answer. -6.04e+09. In the year 2011, what is the difference between the Savings(current US$) of Lao PDR and Savings(current US$) of Paraguay?
Provide a succinct answer. -1.66e+09. In the year 2011, what is the difference between the Savings(current US$) of New Zealand and Savings(current US$) of Paraguay?
Make the answer very short. 4.38e+09. In the year 2012, what is the difference between the Savings(current US$) in Ghana and Savings(current US$) in Lao PDR?
Your response must be concise. 6.18e+09. In the year 2012, what is the difference between the Savings(current US$) of Ghana and Savings(current US$) of New Zealand?
Provide a succinct answer. -1.97e+08. In the year 2012, what is the difference between the Savings(current US$) of Ghana and Savings(current US$) of Paraguay?
Ensure brevity in your answer.  5.78e+09. In the year 2012, what is the difference between the Savings(current US$) of Lao PDR and Savings(current US$) of New Zealand?
Offer a terse response. -6.37e+09. In the year 2012, what is the difference between the Savings(current US$) in Lao PDR and Savings(current US$) in Paraguay?
Your response must be concise. -3.99e+08. In the year 2012, what is the difference between the Savings(current US$) of New Zealand and Savings(current US$) of Paraguay?
Provide a short and direct response. 5.97e+09. What is the ratio of the Savings(current US$) in Ghana in 2005 to that in 2006?
Give a very brief answer. 0.76. What is the ratio of the Savings(current US$) of Lao PDR in 2005 to that in 2006?
Offer a very short reply. 0.01. What is the ratio of the Savings(current US$) of New Zealand in 2005 to that in 2006?
Make the answer very short. 1.41. What is the ratio of the Savings(current US$) in Paraguay in 2005 to that in 2006?
Offer a terse response. 0.62. What is the ratio of the Savings(current US$) in Ghana in 2005 to that in 2007?
Offer a terse response. 1.47. What is the ratio of the Savings(current US$) of Lao PDR in 2005 to that in 2007?
Your answer should be very brief. 0.01. What is the ratio of the Savings(current US$) of New Zealand in 2005 to that in 2007?
Offer a terse response. 0.84. What is the ratio of the Savings(current US$) of Paraguay in 2005 to that in 2007?
Give a very brief answer. 0.4. What is the ratio of the Savings(current US$) in Ghana in 2005 to that in 2008?
Your response must be concise. 2.33. What is the ratio of the Savings(current US$) in Lao PDR in 2005 to that in 2008?
Offer a very short reply. 0.01. What is the ratio of the Savings(current US$) of New Zealand in 2005 to that in 2008?
Keep it short and to the point. 4.74. What is the ratio of the Savings(current US$) of Paraguay in 2005 to that in 2008?
Offer a very short reply. 0.45. What is the ratio of the Savings(current US$) in Ghana in 2005 to that in 2009?
Give a very brief answer. 0.73. What is the ratio of the Savings(current US$) of Lao PDR in 2005 to that in 2009?
Your response must be concise. 0.01. What is the ratio of the Savings(current US$) in New Zealand in 2005 to that in 2009?
Provide a succinct answer. 1.08. What is the ratio of the Savings(current US$) of Paraguay in 2005 to that in 2009?
Offer a very short reply. 0.66. What is the ratio of the Savings(current US$) of Ghana in 2005 to that in 2010?
Ensure brevity in your answer.  0.55. What is the ratio of the Savings(current US$) of Lao PDR in 2005 to that in 2010?
Your answer should be compact. 0.01. What is the ratio of the Savings(current US$) of New Zealand in 2005 to that in 2010?
Ensure brevity in your answer.  0.93. What is the ratio of the Savings(current US$) in Paraguay in 2005 to that in 2010?
Ensure brevity in your answer.  0.47. What is the ratio of the Savings(current US$) in Ghana in 2005 to that in 2011?
Your answer should be very brief. 0.25. What is the ratio of the Savings(current US$) in Lao PDR in 2005 to that in 2011?
Your response must be concise. 0.01. What is the ratio of the Savings(current US$) in New Zealand in 2005 to that in 2011?
Offer a terse response. 0.75. What is the ratio of the Savings(current US$) of Paraguay in 2005 to that in 2011?
Make the answer very short. 0.29. What is the ratio of the Savings(current US$) of Ghana in 2005 to that in 2012?
Your answer should be very brief. 0.21. What is the ratio of the Savings(current US$) in Lao PDR in 2005 to that in 2012?
Make the answer very short. 0.01. What is the ratio of the Savings(current US$) in New Zealand in 2005 to that in 2012?
Make the answer very short. 0.69. What is the ratio of the Savings(current US$) in Paraguay in 2005 to that in 2012?
Offer a terse response. 0.64. What is the ratio of the Savings(current US$) of Ghana in 2006 to that in 2007?
Provide a succinct answer. 1.93. What is the ratio of the Savings(current US$) in Lao PDR in 2006 to that in 2007?
Offer a very short reply. 0.81. What is the ratio of the Savings(current US$) of New Zealand in 2006 to that in 2007?
Ensure brevity in your answer.  0.6. What is the ratio of the Savings(current US$) in Paraguay in 2006 to that in 2007?
Ensure brevity in your answer.  0.64. What is the ratio of the Savings(current US$) in Ghana in 2006 to that in 2008?
Give a very brief answer. 3.05. What is the ratio of the Savings(current US$) in Lao PDR in 2006 to that in 2008?
Your answer should be very brief. 0.97. What is the ratio of the Savings(current US$) of New Zealand in 2006 to that in 2008?
Your answer should be very brief. 3.37. What is the ratio of the Savings(current US$) in Paraguay in 2006 to that in 2008?
Your answer should be compact. 0.72. What is the ratio of the Savings(current US$) in Ghana in 2006 to that in 2009?
Give a very brief answer. 0.95. What is the ratio of the Savings(current US$) in Lao PDR in 2006 to that in 2009?
Offer a very short reply. 0.63. What is the ratio of the Savings(current US$) of New Zealand in 2006 to that in 2009?
Your response must be concise. 0.77. What is the ratio of the Savings(current US$) in Paraguay in 2006 to that in 2009?
Provide a succinct answer. 1.07. What is the ratio of the Savings(current US$) in Ghana in 2006 to that in 2010?
Provide a short and direct response. 0.72. What is the ratio of the Savings(current US$) in Lao PDR in 2006 to that in 2010?
Your answer should be compact. 0.98. What is the ratio of the Savings(current US$) of New Zealand in 2006 to that in 2010?
Offer a terse response. 0.66. What is the ratio of the Savings(current US$) of Paraguay in 2006 to that in 2010?
Your response must be concise. 0.76. What is the ratio of the Savings(current US$) in Ghana in 2006 to that in 2011?
Provide a succinct answer. 0.33. What is the ratio of the Savings(current US$) of Lao PDR in 2006 to that in 2011?
Give a very brief answer. 1. What is the ratio of the Savings(current US$) in New Zealand in 2006 to that in 2011?
Give a very brief answer. 0.53. What is the ratio of the Savings(current US$) in Paraguay in 2006 to that in 2011?
Provide a succinct answer. 0.47. What is the ratio of the Savings(current US$) of Ghana in 2006 to that in 2012?
Your answer should be very brief. 0.28. What is the ratio of the Savings(current US$) of Lao PDR in 2006 to that in 2012?
Offer a terse response. 0.57. What is the ratio of the Savings(current US$) of New Zealand in 2006 to that in 2012?
Your answer should be very brief. 0.49. What is the ratio of the Savings(current US$) of Paraguay in 2006 to that in 2012?
Your response must be concise. 1.03. What is the ratio of the Savings(current US$) in Ghana in 2007 to that in 2008?
Keep it short and to the point. 1.58. What is the ratio of the Savings(current US$) in Lao PDR in 2007 to that in 2008?
Provide a short and direct response. 1.2. What is the ratio of the Savings(current US$) in New Zealand in 2007 to that in 2008?
Provide a short and direct response. 5.63. What is the ratio of the Savings(current US$) in Paraguay in 2007 to that in 2008?
Offer a very short reply. 1.13. What is the ratio of the Savings(current US$) of Ghana in 2007 to that in 2009?
Provide a succinct answer. 0.49. What is the ratio of the Savings(current US$) in Lao PDR in 2007 to that in 2009?
Make the answer very short. 0.78. What is the ratio of the Savings(current US$) of New Zealand in 2007 to that in 2009?
Provide a succinct answer. 1.29. What is the ratio of the Savings(current US$) in Paraguay in 2007 to that in 2009?
Provide a short and direct response. 1.66. What is the ratio of the Savings(current US$) of Ghana in 2007 to that in 2010?
Offer a very short reply. 0.37. What is the ratio of the Savings(current US$) of Lao PDR in 2007 to that in 2010?
Give a very brief answer. 1.21. What is the ratio of the Savings(current US$) in New Zealand in 2007 to that in 2010?
Your answer should be very brief. 1.11. What is the ratio of the Savings(current US$) in Paraguay in 2007 to that in 2010?
Your answer should be compact. 1.18. What is the ratio of the Savings(current US$) in Ghana in 2007 to that in 2011?
Your answer should be very brief. 0.17. What is the ratio of the Savings(current US$) in Lao PDR in 2007 to that in 2011?
Offer a terse response. 1.23. What is the ratio of the Savings(current US$) of New Zealand in 2007 to that in 2011?
Give a very brief answer. 0.89. What is the ratio of the Savings(current US$) in Paraguay in 2007 to that in 2011?
Your response must be concise. 0.73. What is the ratio of the Savings(current US$) in Ghana in 2007 to that in 2012?
Your answer should be compact. 0.15. What is the ratio of the Savings(current US$) of Lao PDR in 2007 to that in 2012?
Your response must be concise. 0.7. What is the ratio of the Savings(current US$) in New Zealand in 2007 to that in 2012?
Provide a succinct answer. 0.82. What is the ratio of the Savings(current US$) in Paraguay in 2007 to that in 2012?
Your response must be concise. 1.6. What is the ratio of the Savings(current US$) of Ghana in 2008 to that in 2009?
Make the answer very short. 0.31. What is the ratio of the Savings(current US$) of Lao PDR in 2008 to that in 2009?
Give a very brief answer. 0.65. What is the ratio of the Savings(current US$) in New Zealand in 2008 to that in 2009?
Offer a terse response. 0.23. What is the ratio of the Savings(current US$) of Paraguay in 2008 to that in 2009?
Make the answer very short. 1.47. What is the ratio of the Savings(current US$) in Ghana in 2008 to that in 2010?
Offer a very short reply. 0.24. What is the ratio of the Savings(current US$) in Lao PDR in 2008 to that in 2010?
Offer a terse response. 1.01. What is the ratio of the Savings(current US$) of New Zealand in 2008 to that in 2010?
Make the answer very short. 0.2. What is the ratio of the Savings(current US$) in Paraguay in 2008 to that in 2010?
Your answer should be compact. 1.05. What is the ratio of the Savings(current US$) in Ghana in 2008 to that in 2011?
Make the answer very short. 0.11. What is the ratio of the Savings(current US$) in Lao PDR in 2008 to that in 2011?
Ensure brevity in your answer.  1.03. What is the ratio of the Savings(current US$) of New Zealand in 2008 to that in 2011?
Give a very brief answer. 0.16. What is the ratio of the Savings(current US$) of Paraguay in 2008 to that in 2011?
Offer a terse response. 0.65. What is the ratio of the Savings(current US$) in Ghana in 2008 to that in 2012?
Offer a very short reply. 0.09. What is the ratio of the Savings(current US$) of Lao PDR in 2008 to that in 2012?
Keep it short and to the point. 0.58. What is the ratio of the Savings(current US$) in New Zealand in 2008 to that in 2012?
Provide a succinct answer. 0.15. What is the ratio of the Savings(current US$) in Paraguay in 2008 to that in 2012?
Ensure brevity in your answer.  1.42. What is the ratio of the Savings(current US$) in Ghana in 2009 to that in 2010?
Offer a terse response. 0.76. What is the ratio of the Savings(current US$) in Lao PDR in 2009 to that in 2010?
Offer a very short reply. 1.55. What is the ratio of the Savings(current US$) in New Zealand in 2009 to that in 2010?
Your answer should be compact. 0.86. What is the ratio of the Savings(current US$) in Paraguay in 2009 to that in 2010?
Your answer should be compact. 0.71. What is the ratio of the Savings(current US$) of Ghana in 2009 to that in 2011?
Offer a terse response. 0.34. What is the ratio of the Savings(current US$) of Lao PDR in 2009 to that in 2011?
Provide a succinct answer. 1.58. What is the ratio of the Savings(current US$) of New Zealand in 2009 to that in 2011?
Offer a very short reply. 0.69. What is the ratio of the Savings(current US$) of Paraguay in 2009 to that in 2011?
Your answer should be very brief. 0.44. What is the ratio of the Savings(current US$) in Ghana in 2009 to that in 2012?
Ensure brevity in your answer.  0.29. What is the ratio of the Savings(current US$) of Lao PDR in 2009 to that in 2012?
Provide a short and direct response. 0.9. What is the ratio of the Savings(current US$) in New Zealand in 2009 to that in 2012?
Your answer should be compact. 0.64. What is the ratio of the Savings(current US$) of Paraguay in 2009 to that in 2012?
Your response must be concise. 0.96. What is the ratio of the Savings(current US$) in Ghana in 2010 to that in 2011?
Provide a short and direct response. 0.45. What is the ratio of the Savings(current US$) in Lao PDR in 2010 to that in 2011?
Offer a terse response. 1.02. What is the ratio of the Savings(current US$) of New Zealand in 2010 to that in 2011?
Ensure brevity in your answer.  0.8. What is the ratio of the Savings(current US$) in Paraguay in 2010 to that in 2011?
Provide a succinct answer. 0.62. What is the ratio of the Savings(current US$) of Ghana in 2010 to that in 2012?
Give a very brief answer. 0.39. What is the ratio of the Savings(current US$) in Lao PDR in 2010 to that in 2012?
Ensure brevity in your answer.  0.58. What is the ratio of the Savings(current US$) in New Zealand in 2010 to that in 2012?
Give a very brief answer. 0.74. What is the ratio of the Savings(current US$) in Paraguay in 2010 to that in 2012?
Offer a very short reply. 1.36. What is the ratio of the Savings(current US$) in Ghana in 2011 to that in 2012?
Ensure brevity in your answer.  0.86. What is the ratio of the Savings(current US$) in Lao PDR in 2011 to that in 2012?
Keep it short and to the point. 0.57. What is the ratio of the Savings(current US$) of New Zealand in 2011 to that in 2012?
Keep it short and to the point. 0.92. What is the ratio of the Savings(current US$) of Paraguay in 2011 to that in 2012?
Offer a very short reply. 2.19. What is the difference between the highest and the second highest Savings(current US$) of Ghana?
Give a very brief answer. 9.31e+08. What is the difference between the highest and the second highest Savings(current US$) in Lao PDR?
Your answer should be compact. 4.82e+07. What is the difference between the highest and the second highest Savings(current US$) of New Zealand?
Make the answer very short. 5.40e+08. What is the difference between the highest and the second highest Savings(current US$) of Paraguay?
Offer a terse response. 5.17e+08. What is the difference between the highest and the lowest Savings(current US$) in Ghana?
Provide a succinct answer. 6.05e+09. What is the difference between the highest and the lowest Savings(current US$) in Lao PDR?
Offer a very short reply. 4.84e+08. What is the difference between the highest and the lowest Savings(current US$) in New Zealand?
Provide a short and direct response. 5.86e+09. What is the difference between the highest and the lowest Savings(current US$) of Paraguay?
Keep it short and to the point. 1.37e+09. 